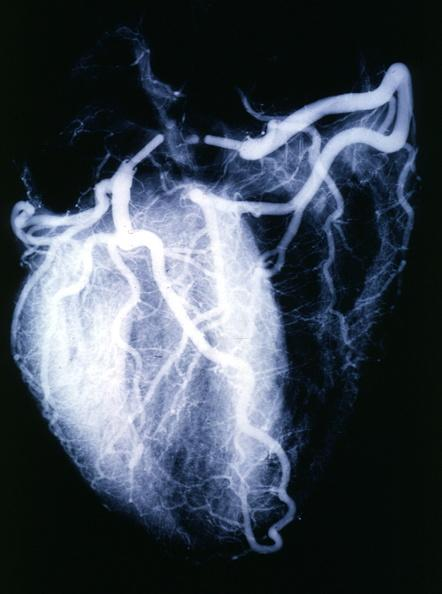does this image show x-ray postmortnormal coronaries?
Answer the question using a single word or phrase. Yes 